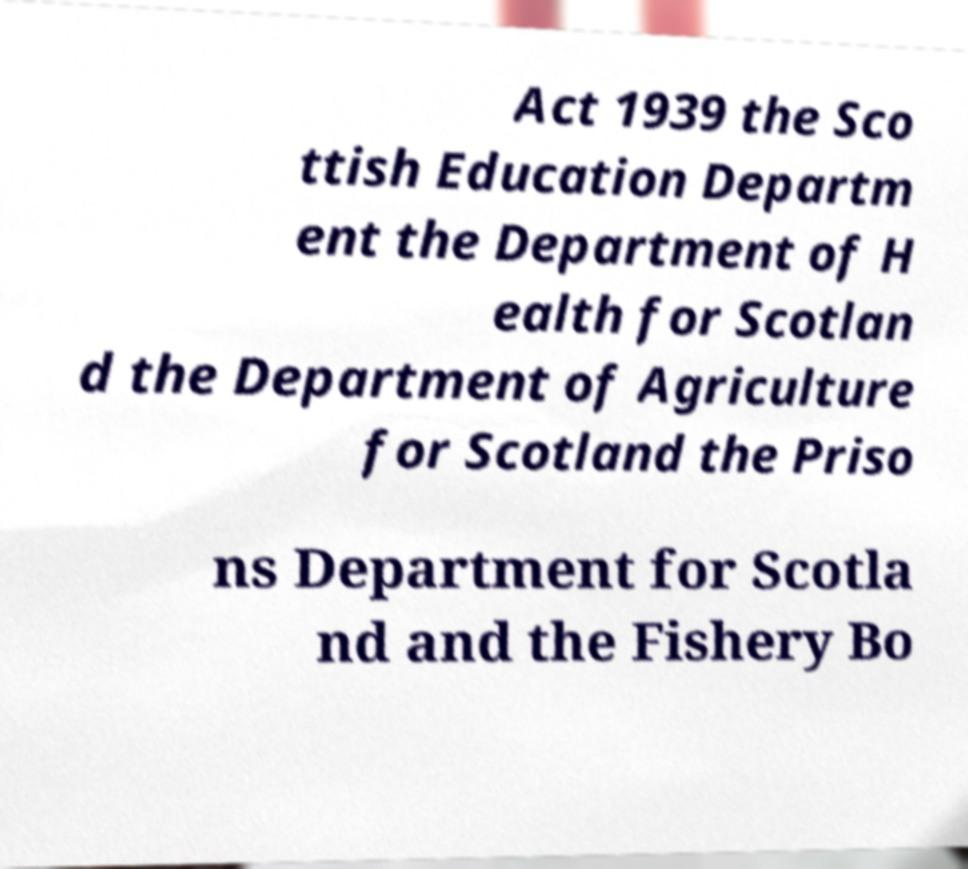For documentation purposes, I need the text within this image transcribed. Could you provide that? Act 1939 the Sco ttish Education Departm ent the Department of H ealth for Scotlan d the Department of Agriculture for Scotland the Priso ns Department for Scotla nd and the Fishery Bo 